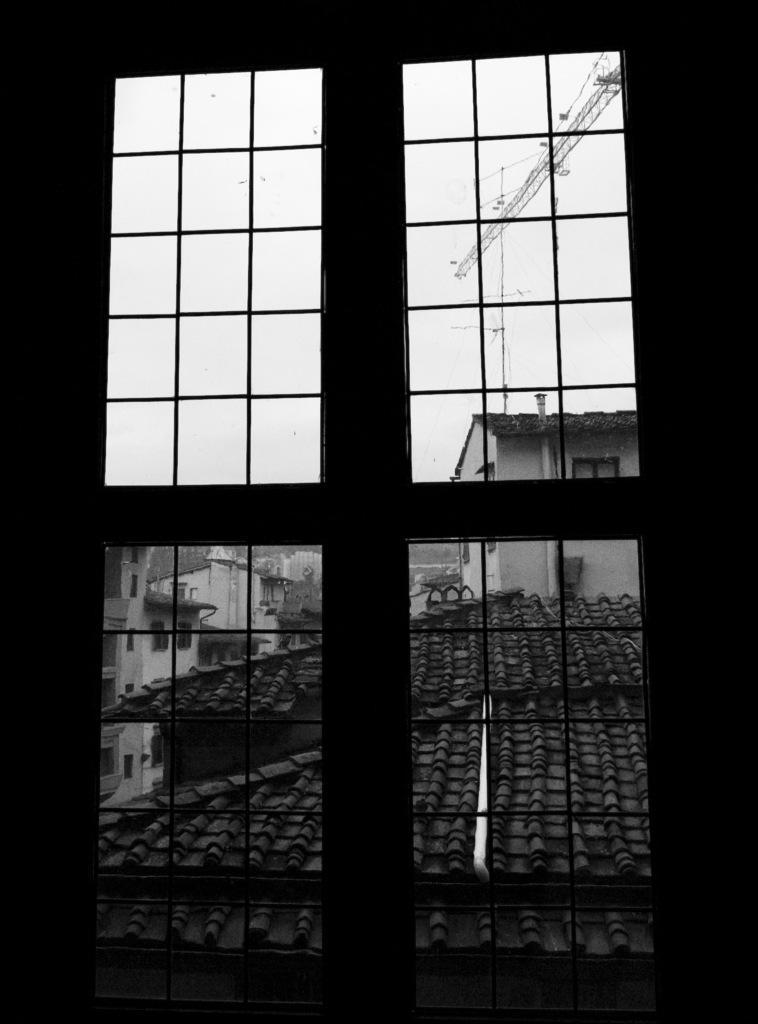In one or two sentences, can you explain what this image depicts? In the foreground of this black and white image, there is a window and through the window, we can see houses, sky and it seems like a crane at the top. 